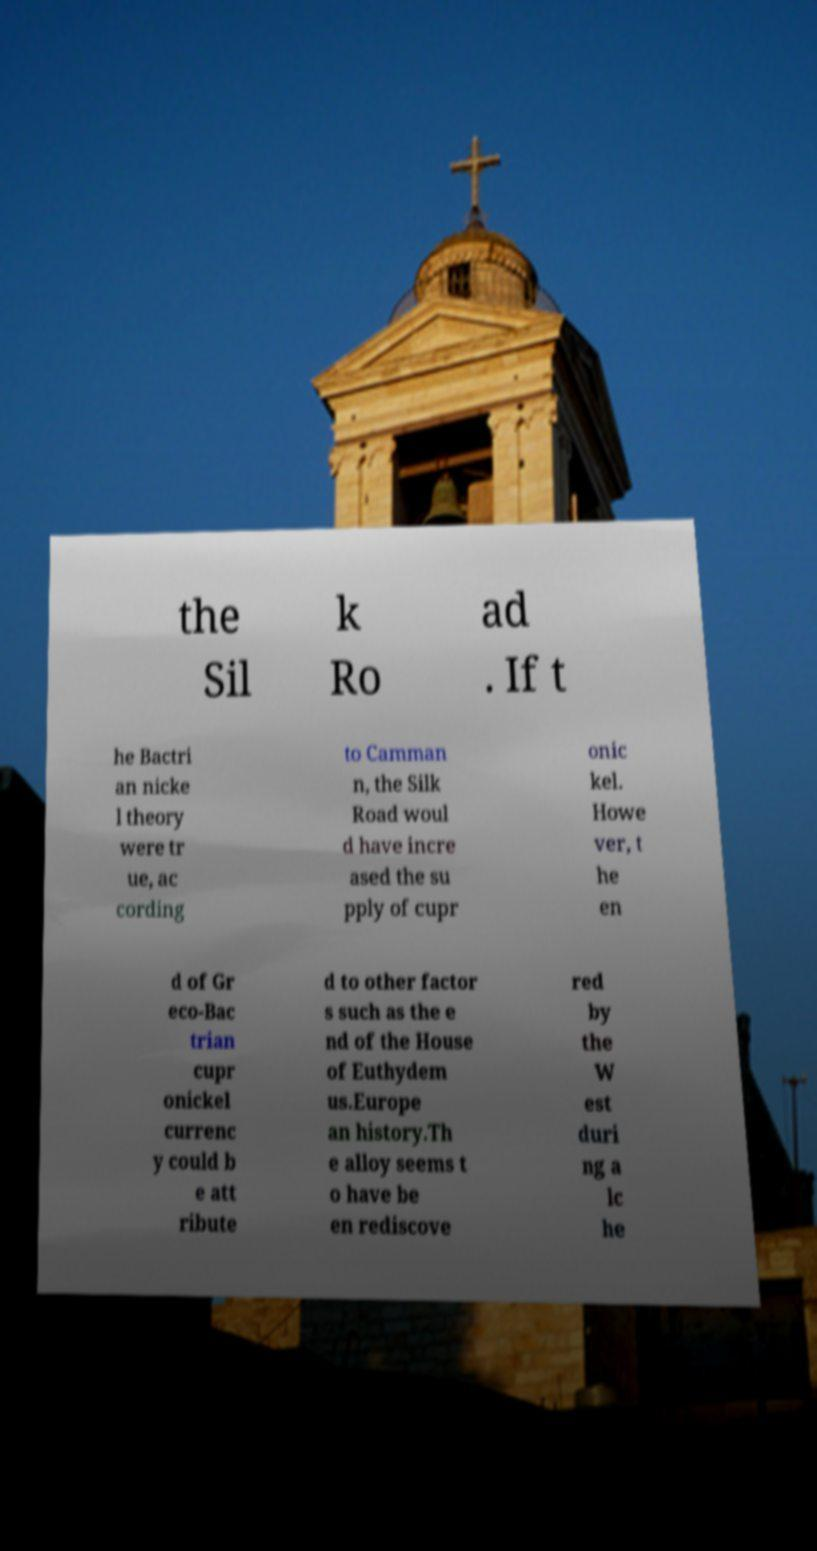Please identify and transcribe the text found in this image. the Sil k Ro ad . If t he Bactri an nicke l theory were tr ue, ac cording to Camman n, the Silk Road woul d have incre ased the su pply of cupr onic kel. Howe ver, t he en d of Gr eco-Bac trian cupr onickel currenc y could b e att ribute d to other factor s such as the e nd of the House of Euthydem us.Europe an history.Th e alloy seems t o have be en rediscove red by the W est duri ng a lc he 